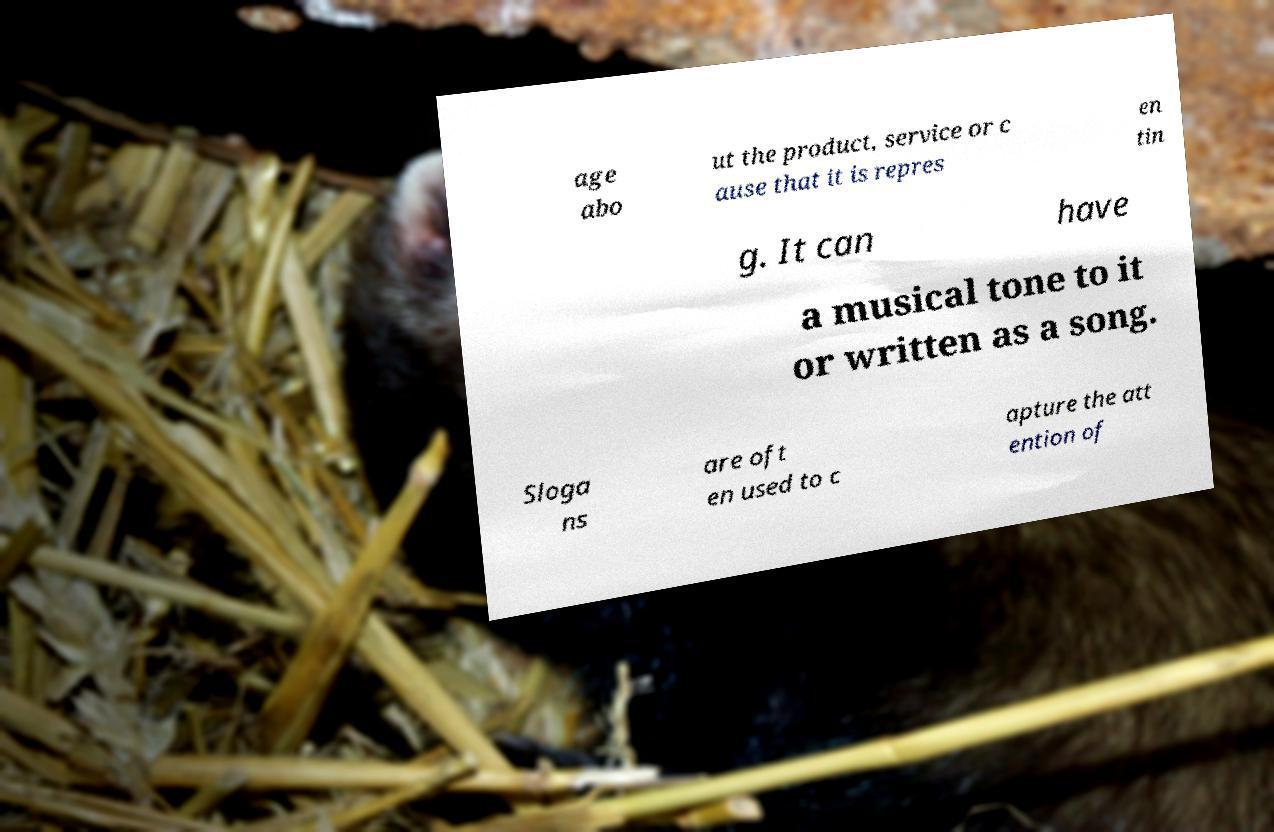What messages or text are displayed in this image? I need them in a readable, typed format. age abo ut the product, service or c ause that it is repres en tin g. It can have a musical tone to it or written as a song. Sloga ns are oft en used to c apture the att ention of 